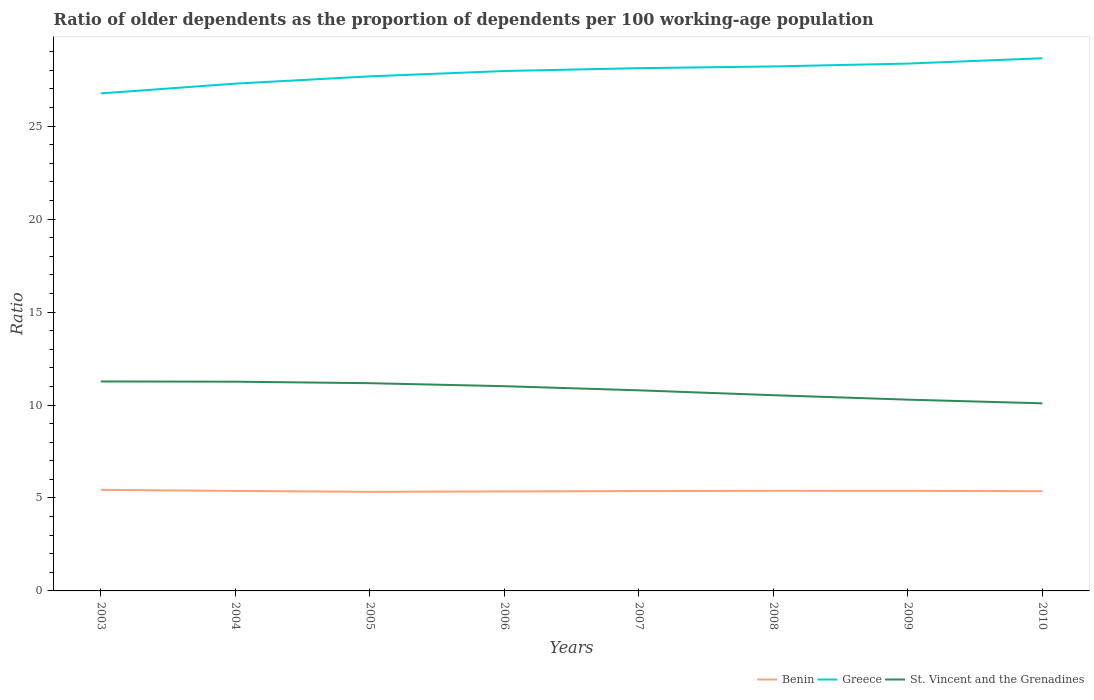Across all years, what is the maximum age dependency ratio(old) in St. Vincent and the Grenadines?
Make the answer very short. 10.09. What is the total age dependency ratio(old) in Benin in the graph?
Your answer should be compact. -0.01. What is the difference between the highest and the second highest age dependency ratio(old) in St. Vincent and the Grenadines?
Make the answer very short. 1.18. What is the difference between the highest and the lowest age dependency ratio(old) in Greece?
Your response must be concise. 5. Is the age dependency ratio(old) in Greece strictly greater than the age dependency ratio(old) in St. Vincent and the Grenadines over the years?
Your answer should be very brief. No. How many lines are there?
Your answer should be very brief. 3. How many years are there in the graph?
Offer a terse response. 8. What is the difference between two consecutive major ticks on the Y-axis?
Your answer should be compact. 5. Are the values on the major ticks of Y-axis written in scientific E-notation?
Provide a short and direct response. No. Where does the legend appear in the graph?
Provide a short and direct response. Bottom right. How are the legend labels stacked?
Offer a terse response. Horizontal. What is the title of the graph?
Give a very brief answer. Ratio of older dependents as the proportion of dependents per 100 working-age population. Does "Armenia" appear as one of the legend labels in the graph?
Your answer should be very brief. No. What is the label or title of the X-axis?
Ensure brevity in your answer.  Years. What is the label or title of the Y-axis?
Offer a terse response. Ratio. What is the Ratio in Benin in 2003?
Provide a short and direct response. 5.44. What is the Ratio of Greece in 2003?
Ensure brevity in your answer.  26.76. What is the Ratio in St. Vincent and the Grenadines in 2003?
Offer a terse response. 11.27. What is the Ratio of Benin in 2004?
Your answer should be compact. 5.38. What is the Ratio in Greece in 2004?
Give a very brief answer. 27.29. What is the Ratio of St. Vincent and the Grenadines in 2004?
Ensure brevity in your answer.  11.25. What is the Ratio of Benin in 2005?
Give a very brief answer. 5.33. What is the Ratio of Greece in 2005?
Your response must be concise. 27.68. What is the Ratio of St. Vincent and the Grenadines in 2005?
Offer a very short reply. 11.17. What is the Ratio of Benin in 2006?
Your answer should be compact. 5.35. What is the Ratio of Greece in 2006?
Offer a terse response. 27.97. What is the Ratio in St. Vincent and the Grenadines in 2006?
Provide a succinct answer. 11.01. What is the Ratio of Benin in 2007?
Ensure brevity in your answer.  5.37. What is the Ratio of Greece in 2007?
Provide a short and direct response. 28.12. What is the Ratio in St. Vincent and the Grenadines in 2007?
Your answer should be compact. 10.79. What is the Ratio in Benin in 2008?
Provide a short and direct response. 5.38. What is the Ratio of Greece in 2008?
Provide a succinct answer. 28.21. What is the Ratio of St. Vincent and the Grenadines in 2008?
Offer a terse response. 10.53. What is the Ratio in Benin in 2009?
Ensure brevity in your answer.  5.38. What is the Ratio in Greece in 2009?
Give a very brief answer. 28.36. What is the Ratio in St. Vincent and the Grenadines in 2009?
Give a very brief answer. 10.29. What is the Ratio in Benin in 2010?
Provide a succinct answer. 5.36. What is the Ratio in Greece in 2010?
Keep it short and to the point. 28.65. What is the Ratio of St. Vincent and the Grenadines in 2010?
Your answer should be very brief. 10.09. Across all years, what is the maximum Ratio of Benin?
Keep it short and to the point. 5.44. Across all years, what is the maximum Ratio of Greece?
Offer a terse response. 28.65. Across all years, what is the maximum Ratio in St. Vincent and the Grenadines?
Provide a succinct answer. 11.27. Across all years, what is the minimum Ratio of Benin?
Ensure brevity in your answer.  5.33. Across all years, what is the minimum Ratio in Greece?
Provide a short and direct response. 26.76. Across all years, what is the minimum Ratio of St. Vincent and the Grenadines?
Your response must be concise. 10.09. What is the total Ratio of Benin in the graph?
Offer a very short reply. 43. What is the total Ratio in Greece in the graph?
Ensure brevity in your answer.  223.03. What is the total Ratio in St. Vincent and the Grenadines in the graph?
Offer a very short reply. 86.4. What is the difference between the Ratio in Benin in 2003 and that in 2004?
Provide a short and direct response. 0.06. What is the difference between the Ratio in Greece in 2003 and that in 2004?
Provide a short and direct response. -0.53. What is the difference between the Ratio in St. Vincent and the Grenadines in 2003 and that in 2004?
Offer a terse response. 0.01. What is the difference between the Ratio in Benin in 2003 and that in 2005?
Give a very brief answer. 0.11. What is the difference between the Ratio of Greece in 2003 and that in 2005?
Give a very brief answer. -0.92. What is the difference between the Ratio in St. Vincent and the Grenadines in 2003 and that in 2005?
Offer a terse response. 0.09. What is the difference between the Ratio of Benin in 2003 and that in 2006?
Offer a terse response. 0.09. What is the difference between the Ratio in Greece in 2003 and that in 2006?
Provide a short and direct response. -1.2. What is the difference between the Ratio of St. Vincent and the Grenadines in 2003 and that in 2006?
Your response must be concise. 0.25. What is the difference between the Ratio in Benin in 2003 and that in 2007?
Your answer should be compact. 0.07. What is the difference between the Ratio in Greece in 2003 and that in 2007?
Provide a short and direct response. -1.36. What is the difference between the Ratio in St. Vincent and the Grenadines in 2003 and that in 2007?
Keep it short and to the point. 0.48. What is the difference between the Ratio in Benin in 2003 and that in 2008?
Provide a succinct answer. 0.05. What is the difference between the Ratio of Greece in 2003 and that in 2008?
Your answer should be very brief. -1.45. What is the difference between the Ratio of St. Vincent and the Grenadines in 2003 and that in 2008?
Your answer should be compact. 0.74. What is the difference between the Ratio of Benin in 2003 and that in 2009?
Provide a succinct answer. 0.06. What is the difference between the Ratio of Greece in 2003 and that in 2009?
Ensure brevity in your answer.  -1.6. What is the difference between the Ratio in St. Vincent and the Grenadines in 2003 and that in 2009?
Provide a short and direct response. 0.98. What is the difference between the Ratio in Benin in 2003 and that in 2010?
Offer a very short reply. 0.07. What is the difference between the Ratio in Greece in 2003 and that in 2010?
Your response must be concise. -1.89. What is the difference between the Ratio of St. Vincent and the Grenadines in 2003 and that in 2010?
Ensure brevity in your answer.  1.18. What is the difference between the Ratio of Benin in 2004 and that in 2005?
Provide a succinct answer. 0.05. What is the difference between the Ratio in Greece in 2004 and that in 2005?
Your answer should be compact. -0.39. What is the difference between the Ratio of St. Vincent and the Grenadines in 2004 and that in 2005?
Offer a very short reply. 0.08. What is the difference between the Ratio of Benin in 2004 and that in 2006?
Your response must be concise. 0.03. What is the difference between the Ratio of Greece in 2004 and that in 2006?
Make the answer very short. -0.68. What is the difference between the Ratio of St. Vincent and the Grenadines in 2004 and that in 2006?
Ensure brevity in your answer.  0.24. What is the difference between the Ratio in Benin in 2004 and that in 2007?
Offer a very short reply. 0.01. What is the difference between the Ratio in Greece in 2004 and that in 2007?
Your response must be concise. -0.83. What is the difference between the Ratio in St. Vincent and the Grenadines in 2004 and that in 2007?
Your response must be concise. 0.47. What is the difference between the Ratio in Benin in 2004 and that in 2008?
Your response must be concise. -0.01. What is the difference between the Ratio in Greece in 2004 and that in 2008?
Give a very brief answer. -0.92. What is the difference between the Ratio in St. Vincent and the Grenadines in 2004 and that in 2008?
Give a very brief answer. 0.73. What is the difference between the Ratio in Benin in 2004 and that in 2009?
Ensure brevity in your answer.  -0. What is the difference between the Ratio in Greece in 2004 and that in 2009?
Offer a very short reply. -1.08. What is the difference between the Ratio in St. Vincent and the Grenadines in 2004 and that in 2009?
Provide a short and direct response. 0.97. What is the difference between the Ratio of Benin in 2004 and that in 2010?
Offer a terse response. 0.02. What is the difference between the Ratio in Greece in 2004 and that in 2010?
Your response must be concise. -1.36. What is the difference between the Ratio of St. Vincent and the Grenadines in 2004 and that in 2010?
Ensure brevity in your answer.  1.16. What is the difference between the Ratio in Benin in 2005 and that in 2006?
Provide a succinct answer. -0.02. What is the difference between the Ratio of Greece in 2005 and that in 2006?
Offer a terse response. -0.29. What is the difference between the Ratio of St. Vincent and the Grenadines in 2005 and that in 2006?
Provide a succinct answer. 0.16. What is the difference between the Ratio of Benin in 2005 and that in 2007?
Your answer should be compact. -0.04. What is the difference between the Ratio of Greece in 2005 and that in 2007?
Make the answer very short. -0.44. What is the difference between the Ratio in St. Vincent and the Grenadines in 2005 and that in 2007?
Provide a succinct answer. 0.38. What is the difference between the Ratio of Benin in 2005 and that in 2008?
Give a very brief answer. -0.05. What is the difference between the Ratio of Greece in 2005 and that in 2008?
Ensure brevity in your answer.  -0.53. What is the difference between the Ratio in St. Vincent and the Grenadines in 2005 and that in 2008?
Provide a short and direct response. 0.65. What is the difference between the Ratio in Benin in 2005 and that in 2009?
Your answer should be compact. -0.05. What is the difference between the Ratio in Greece in 2005 and that in 2009?
Ensure brevity in your answer.  -0.69. What is the difference between the Ratio in St. Vincent and the Grenadines in 2005 and that in 2009?
Provide a short and direct response. 0.89. What is the difference between the Ratio of Benin in 2005 and that in 2010?
Provide a succinct answer. -0.03. What is the difference between the Ratio in Greece in 2005 and that in 2010?
Offer a terse response. -0.97. What is the difference between the Ratio of St. Vincent and the Grenadines in 2005 and that in 2010?
Provide a short and direct response. 1.08. What is the difference between the Ratio in Benin in 2006 and that in 2007?
Ensure brevity in your answer.  -0.02. What is the difference between the Ratio of Greece in 2006 and that in 2007?
Keep it short and to the point. -0.15. What is the difference between the Ratio in St. Vincent and the Grenadines in 2006 and that in 2007?
Keep it short and to the point. 0.22. What is the difference between the Ratio in Benin in 2006 and that in 2008?
Provide a short and direct response. -0.03. What is the difference between the Ratio of Greece in 2006 and that in 2008?
Make the answer very short. -0.25. What is the difference between the Ratio of St. Vincent and the Grenadines in 2006 and that in 2008?
Your answer should be compact. 0.49. What is the difference between the Ratio in Benin in 2006 and that in 2009?
Your answer should be very brief. -0.03. What is the difference between the Ratio of Greece in 2006 and that in 2009?
Offer a terse response. -0.4. What is the difference between the Ratio of St. Vincent and the Grenadines in 2006 and that in 2009?
Ensure brevity in your answer.  0.72. What is the difference between the Ratio in Benin in 2006 and that in 2010?
Give a very brief answer. -0.01. What is the difference between the Ratio in Greece in 2006 and that in 2010?
Provide a short and direct response. -0.69. What is the difference between the Ratio in St. Vincent and the Grenadines in 2006 and that in 2010?
Provide a succinct answer. 0.92. What is the difference between the Ratio of Benin in 2007 and that in 2008?
Offer a terse response. -0.01. What is the difference between the Ratio of Greece in 2007 and that in 2008?
Your answer should be compact. -0.09. What is the difference between the Ratio of St. Vincent and the Grenadines in 2007 and that in 2008?
Your answer should be very brief. 0.26. What is the difference between the Ratio of Benin in 2007 and that in 2009?
Provide a short and direct response. -0.01. What is the difference between the Ratio of Greece in 2007 and that in 2009?
Give a very brief answer. -0.25. What is the difference between the Ratio in St. Vincent and the Grenadines in 2007 and that in 2009?
Ensure brevity in your answer.  0.5. What is the difference between the Ratio of Benin in 2007 and that in 2010?
Your response must be concise. 0.01. What is the difference between the Ratio in Greece in 2007 and that in 2010?
Provide a succinct answer. -0.53. What is the difference between the Ratio of St. Vincent and the Grenadines in 2007 and that in 2010?
Your answer should be compact. 0.7. What is the difference between the Ratio of Benin in 2008 and that in 2009?
Offer a very short reply. 0. What is the difference between the Ratio in Greece in 2008 and that in 2009?
Offer a terse response. -0.15. What is the difference between the Ratio of St. Vincent and the Grenadines in 2008 and that in 2009?
Make the answer very short. 0.24. What is the difference between the Ratio in Benin in 2008 and that in 2010?
Your answer should be very brief. 0.02. What is the difference between the Ratio of Greece in 2008 and that in 2010?
Make the answer very short. -0.44. What is the difference between the Ratio in St. Vincent and the Grenadines in 2008 and that in 2010?
Your answer should be compact. 0.44. What is the difference between the Ratio of Benin in 2009 and that in 2010?
Offer a very short reply. 0.02. What is the difference between the Ratio of Greece in 2009 and that in 2010?
Make the answer very short. -0.29. What is the difference between the Ratio in St. Vincent and the Grenadines in 2009 and that in 2010?
Provide a succinct answer. 0.2. What is the difference between the Ratio of Benin in 2003 and the Ratio of Greece in 2004?
Give a very brief answer. -21.85. What is the difference between the Ratio in Benin in 2003 and the Ratio in St. Vincent and the Grenadines in 2004?
Provide a short and direct response. -5.82. What is the difference between the Ratio of Greece in 2003 and the Ratio of St. Vincent and the Grenadines in 2004?
Ensure brevity in your answer.  15.51. What is the difference between the Ratio in Benin in 2003 and the Ratio in Greece in 2005?
Give a very brief answer. -22.24. What is the difference between the Ratio of Benin in 2003 and the Ratio of St. Vincent and the Grenadines in 2005?
Your answer should be very brief. -5.74. What is the difference between the Ratio in Greece in 2003 and the Ratio in St. Vincent and the Grenadines in 2005?
Offer a very short reply. 15.59. What is the difference between the Ratio of Benin in 2003 and the Ratio of Greece in 2006?
Offer a terse response. -22.53. What is the difference between the Ratio of Benin in 2003 and the Ratio of St. Vincent and the Grenadines in 2006?
Offer a very short reply. -5.57. What is the difference between the Ratio of Greece in 2003 and the Ratio of St. Vincent and the Grenadines in 2006?
Your answer should be compact. 15.75. What is the difference between the Ratio of Benin in 2003 and the Ratio of Greece in 2007?
Your response must be concise. -22.68. What is the difference between the Ratio of Benin in 2003 and the Ratio of St. Vincent and the Grenadines in 2007?
Your answer should be compact. -5.35. What is the difference between the Ratio in Greece in 2003 and the Ratio in St. Vincent and the Grenadines in 2007?
Ensure brevity in your answer.  15.97. What is the difference between the Ratio of Benin in 2003 and the Ratio of Greece in 2008?
Offer a terse response. -22.77. What is the difference between the Ratio in Benin in 2003 and the Ratio in St. Vincent and the Grenadines in 2008?
Your answer should be compact. -5.09. What is the difference between the Ratio in Greece in 2003 and the Ratio in St. Vincent and the Grenadines in 2008?
Offer a very short reply. 16.23. What is the difference between the Ratio of Benin in 2003 and the Ratio of Greece in 2009?
Ensure brevity in your answer.  -22.93. What is the difference between the Ratio in Benin in 2003 and the Ratio in St. Vincent and the Grenadines in 2009?
Ensure brevity in your answer.  -4.85. What is the difference between the Ratio in Greece in 2003 and the Ratio in St. Vincent and the Grenadines in 2009?
Make the answer very short. 16.47. What is the difference between the Ratio of Benin in 2003 and the Ratio of Greece in 2010?
Give a very brief answer. -23.21. What is the difference between the Ratio in Benin in 2003 and the Ratio in St. Vincent and the Grenadines in 2010?
Make the answer very short. -4.65. What is the difference between the Ratio in Greece in 2003 and the Ratio in St. Vincent and the Grenadines in 2010?
Provide a succinct answer. 16.67. What is the difference between the Ratio in Benin in 2004 and the Ratio in Greece in 2005?
Offer a terse response. -22.3. What is the difference between the Ratio in Benin in 2004 and the Ratio in St. Vincent and the Grenadines in 2005?
Keep it short and to the point. -5.8. What is the difference between the Ratio in Greece in 2004 and the Ratio in St. Vincent and the Grenadines in 2005?
Provide a short and direct response. 16.11. What is the difference between the Ratio of Benin in 2004 and the Ratio of Greece in 2006?
Offer a very short reply. -22.59. What is the difference between the Ratio in Benin in 2004 and the Ratio in St. Vincent and the Grenadines in 2006?
Give a very brief answer. -5.63. What is the difference between the Ratio in Greece in 2004 and the Ratio in St. Vincent and the Grenadines in 2006?
Provide a succinct answer. 16.27. What is the difference between the Ratio in Benin in 2004 and the Ratio in Greece in 2007?
Ensure brevity in your answer.  -22.74. What is the difference between the Ratio in Benin in 2004 and the Ratio in St. Vincent and the Grenadines in 2007?
Offer a very short reply. -5.41. What is the difference between the Ratio in Greece in 2004 and the Ratio in St. Vincent and the Grenadines in 2007?
Ensure brevity in your answer.  16.5. What is the difference between the Ratio of Benin in 2004 and the Ratio of Greece in 2008?
Offer a very short reply. -22.83. What is the difference between the Ratio in Benin in 2004 and the Ratio in St. Vincent and the Grenadines in 2008?
Your response must be concise. -5.15. What is the difference between the Ratio in Greece in 2004 and the Ratio in St. Vincent and the Grenadines in 2008?
Offer a very short reply. 16.76. What is the difference between the Ratio in Benin in 2004 and the Ratio in Greece in 2009?
Your answer should be compact. -22.99. What is the difference between the Ratio in Benin in 2004 and the Ratio in St. Vincent and the Grenadines in 2009?
Your answer should be very brief. -4.91. What is the difference between the Ratio of Greece in 2004 and the Ratio of St. Vincent and the Grenadines in 2009?
Provide a short and direct response. 17. What is the difference between the Ratio of Benin in 2004 and the Ratio of Greece in 2010?
Ensure brevity in your answer.  -23.27. What is the difference between the Ratio of Benin in 2004 and the Ratio of St. Vincent and the Grenadines in 2010?
Provide a short and direct response. -4.71. What is the difference between the Ratio of Greece in 2004 and the Ratio of St. Vincent and the Grenadines in 2010?
Make the answer very short. 17.2. What is the difference between the Ratio in Benin in 2005 and the Ratio in Greece in 2006?
Make the answer very short. -22.63. What is the difference between the Ratio in Benin in 2005 and the Ratio in St. Vincent and the Grenadines in 2006?
Your response must be concise. -5.68. What is the difference between the Ratio in Greece in 2005 and the Ratio in St. Vincent and the Grenadines in 2006?
Provide a short and direct response. 16.67. What is the difference between the Ratio of Benin in 2005 and the Ratio of Greece in 2007?
Offer a terse response. -22.79. What is the difference between the Ratio of Benin in 2005 and the Ratio of St. Vincent and the Grenadines in 2007?
Offer a very short reply. -5.46. What is the difference between the Ratio in Greece in 2005 and the Ratio in St. Vincent and the Grenadines in 2007?
Provide a succinct answer. 16.89. What is the difference between the Ratio of Benin in 2005 and the Ratio of Greece in 2008?
Offer a terse response. -22.88. What is the difference between the Ratio of Benin in 2005 and the Ratio of St. Vincent and the Grenadines in 2008?
Your answer should be compact. -5.2. What is the difference between the Ratio of Greece in 2005 and the Ratio of St. Vincent and the Grenadines in 2008?
Your answer should be compact. 17.15. What is the difference between the Ratio of Benin in 2005 and the Ratio of Greece in 2009?
Offer a terse response. -23.03. What is the difference between the Ratio in Benin in 2005 and the Ratio in St. Vincent and the Grenadines in 2009?
Make the answer very short. -4.96. What is the difference between the Ratio in Greece in 2005 and the Ratio in St. Vincent and the Grenadines in 2009?
Your answer should be very brief. 17.39. What is the difference between the Ratio of Benin in 2005 and the Ratio of Greece in 2010?
Give a very brief answer. -23.32. What is the difference between the Ratio of Benin in 2005 and the Ratio of St. Vincent and the Grenadines in 2010?
Provide a short and direct response. -4.76. What is the difference between the Ratio in Greece in 2005 and the Ratio in St. Vincent and the Grenadines in 2010?
Offer a very short reply. 17.59. What is the difference between the Ratio in Benin in 2006 and the Ratio in Greece in 2007?
Offer a very short reply. -22.77. What is the difference between the Ratio in Benin in 2006 and the Ratio in St. Vincent and the Grenadines in 2007?
Your response must be concise. -5.44. What is the difference between the Ratio of Greece in 2006 and the Ratio of St. Vincent and the Grenadines in 2007?
Offer a terse response. 17.18. What is the difference between the Ratio of Benin in 2006 and the Ratio of Greece in 2008?
Your response must be concise. -22.86. What is the difference between the Ratio in Benin in 2006 and the Ratio in St. Vincent and the Grenadines in 2008?
Give a very brief answer. -5.18. What is the difference between the Ratio in Greece in 2006 and the Ratio in St. Vincent and the Grenadines in 2008?
Keep it short and to the point. 17.44. What is the difference between the Ratio in Benin in 2006 and the Ratio in Greece in 2009?
Offer a very short reply. -23.01. What is the difference between the Ratio of Benin in 2006 and the Ratio of St. Vincent and the Grenadines in 2009?
Your response must be concise. -4.94. What is the difference between the Ratio in Greece in 2006 and the Ratio in St. Vincent and the Grenadines in 2009?
Offer a terse response. 17.68. What is the difference between the Ratio of Benin in 2006 and the Ratio of Greece in 2010?
Make the answer very short. -23.3. What is the difference between the Ratio in Benin in 2006 and the Ratio in St. Vincent and the Grenadines in 2010?
Keep it short and to the point. -4.74. What is the difference between the Ratio in Greece in 2006 and the Ratio in St. Vincent and the Grenadines in 2010?
Ensure brevity in your answer.  17.87. What is the difference between the Ratio of Benin in 2007 and the Ratio of Greece in 2008?
Offer a very short reply. -22.84. What is the difference between the Ratio of Benin in 2007 and the Ratio of St. Vincent and the Grenadines in 2008?
Offer a terse response. -5.16. What is the difference between the Ratio of Greece in 2007 and the Ratio of St. Vincent and the Grenadines in 2008?
Provide a succinct answer. 17.59. What is the difference between the Ratio of Benin in 2007 and the Ratio of Greece in 2009?
Offer a terse response. -22.99. What is the difference between the Ratio in Benin in 2007 and the Ratio in St. Vincent and the Grenadines in 2009?
Make the answer very short. -4.92. What is the difference between the Ratio of Greece in 2007 and the Ratio of St. Vincent and the Grenadines in 2009?
Make the answer very short. 17.83. What is the difference between the Ratio of Benin in 2007 and the Ratio of Greece in 2010?
Keep it short and to the point. -23.28. What is the difference between the Ratio in Benin in 2007 and the Ratio in St. Vincent and the Grenadines in 2010?
Your answer should be very brief. -4.72. What is the difference between the Ratio of Greece in 2007 and the Ratio of St. Vincent and the Grenadines in 2010?
Make the answer very short. 18.03. What is the difference between the Ratio in Benin in 2008 and the Ratio in Greece in 2009?
Provide a short and direct response. -22.98. What is the difference between the Ratio in Benin in 2008 and the Ratio in St. Vincent and the Grenadines in 2009?
Offer a very short reply. -4.9. What is the difference between the Ratio in Greece in 2008 and the Ratio in St. Vincent and the Grenadines in 2009?
Make the answer very short. 17.92. What is the difference between the Ratio in Benin in 2008 and the Ratio in Greece in 2010?
Your answer should be compact. -23.27. What is the difference between the Ratio in Benin in 2008 and the Ratio in St. Vincent and the Grenadines in 2010?
Your answer should be very brief. -4.71. What is the difference between the Ratio in Greece in 2008 and the Ratio in St. Vincent and the Grenadines in 2010?
Ensure brevity in your answer.  18.12. What is the difference between the Ratio of Benin in 2009 and the Ratio of Greece in 2010?
Make the answer very short. -23.27. What is the difference between the Ratio of Benin in 2009 and the Ratio of St. Vincent and the Grenadines in 2010?
Ensure brevity in your answer.  -4.71. What is the difference between the Ratio in Greece in 2009 and the Ratio in St. Vincent and the Grenadines in 2010?
Your answer should be compact. 18.27. What is the average Ratio in Benin per year?
Make the answer very short. 5.37. What is the average Ratio of Greece per year?
Offer a terse response. 27.88. What is the average Ratio in St. Vincent and the Grenadines per year?
Your response must be concise. 10.8. In the year 2003, what is the difference between the Ratio of Benin and Ratio of Greece?
Provide a succinct answer. -21.32. In the year 2003, what is the difference between the Ratio in Benin and Ratio in St. Vincent and the Grenadines?
Offer a very short reply. -5.83. In the year 2003, what is the difference between the Ratio of Greece and Ratio of St. Vincent and the Grenadines?
Your answer should be compact. 15.49. In the year 2004, what is the difference between the Ratio of Benin and Ratio of Greece?
Make the answer very short. -21.91. In the year 2004, what is the difference between the Ratio of Benin and Ratio of St. Vincent and the Grenadines?
Provide a succinct answer. -5.88. In the year 2004, what is the difference between the Ratio in Greece and Ratio in St. Vincent and the Grenadines?
Keep it short and to the point. 16.03. In the year 2005, what is the difference between the Ratio in Benin and Ratio in Greece?
Ensure brevity in your answer.  -22.35. In the year 2005, what is the difference between the Ratio in Benin and Ratio in St. Vincent and the Grenadines?
Your answer should be very brief. -5.84. In the year 2005, what is the difference between the Ratio of Greece and Ratio of St. Vincent and the Grenadines?
Provide a short and direct response. 16.5. In the year 2006, what is the difference between the Ratio of Benin and Ratio of Greece?
Your answer should be very brief. -22.61. In the year 2006, what is the difference between the Ratio in Benin and Ratio in St. Vincent and the Grenadines?
Give a very brief answer. -5.66. In the year 2006, what is the difference between the Ratio in Greece and Ratio in St. Vincent and the Grenadines?
Give a very brief answer. 16.95. In the year 2007, what is the difference between the Ratio in Benin and Ratio in Greece?
Your answer should be compact. -22.75. In the year 2007, what is the difference between the Ratio of Benin and Ratio of St. Vincent and the Grenadines?
Your answer should be compact. -5.42. In the year 2007, what is the difference between the Ratio in Greece and Ratio in St. Vincent and the Grenadines?
Provide a succinct answer. 17.33. In the year 2008, what is the difference between the Ratio in Benin and Ratio in Greece?
Offer a terse response. -22.83. In the year 2008, what is the difference between the Ratio in Benin and Ratio in St. Vincent and the Grenadines?
Give a very brief answer. -5.14. In the year 2008, what is the difference between the Ratio in Greece and Ratio in St. Vincent and the Grenadines?
Your response must be concise. 17.68. In the year 2009, what is the difference between the Ratio in Benin and Ratio in Greece?
Provide a short and direct response. -22.98. In the year 2009, what is the difference between the Ratio of Benin and Ratio of St. Vincent and the Grenadines?
Your answer should be very brief. -4.91. In the year 2009, what is the difference between the Ratio of Greece and Ratio of St. Vincent and the Grenadines?
Give a very brief answer. 18.08. In the year 2010, what is the difference between the Ratio in Benin and Ratio in Greece?
Your answer should be very brief. -23.29. In the year 2010, what is the difference between the Ratio of Benin and Ratio of St. Vincent and the Grenadines?
Your answer should be compact. -4.73. In the year 2010, what is the difference between the Ratio in Greece and Ratio in St. Vincent and the Grenadines?
Offer a terse response. 18.56. What is the ratio of the Ratio of Benin in 2003 to that in 2004?
Your response must be concise. 1.01. What is the ratio of the Ratio of Greece in 2003 to that in 2004?
Make the answer very short. 0.98. What is the ratio of the Ratio in St. Vincent and the Grenadines in 2003 to that in 2004?
Keep it short and to the point. 1. What is the ratio of the Ratio of Greece in 2003 to that in 2005?
Offer a very short reply. 0.97. What is the ratio of the Ratio of St. Vincent and the Grenadines in 2003 to that in 2005?
Give a very brief answer. 1.01. What is the ratio of the Ratio in Benin in 2003 to that in 2006?
Your answer should be compact. 1.02. What is the ratio of the Ratio in Greece in 2003 to that in 2006?
Give a very brief answer. 0.96. What is the ratio of the Ratio of St. Vincent and the Grenadines in 2003 to that in 2006?
Ensure brevity in your answer.  1.02. What is the ratio of the Ratio in Benin in 2003 to that in 2007?
Ensure brevity in your answer.  1.01. What is the ratio of the Ratio of Greece in 2003 to that in 2007?
Offer a very short reply. 0.95. What is the ratio of the Ratio in St. Vincent and the Grenadines in 2003 to that in 2007?
Offer a very short reply. 1.04. What is the ratio of the Ratio of Greece in 2003 to that in 2008?
Make the answer very short. 0.95. What is the ratio of the Ratio in St. Vincent and the Grenadines in 2003 to that in 2008?
Your answer should be compact. 1.07. What is the ratio of the Ratio of Benin in 2003 to that in 2009?
Give a very brief answer. 1.01. What is the ratio of the Ratio of Greece in 2003 to that in 2009?
Offer a very short reply. 0.94. What is the ratio of the Ratio in St. Vincent and the Grenadines in 2003 to that in 2009?
Your answer should be very brief. 1.1. What is the ratio of the Ratio of Benin in 2003 to that in 2010?
Offer a terse response. 1.01. What is the ratio of the Ratio in Greece in 2003 to that in 2010?
Offer a very short reply. 0.93. What is the ratio of the Ratio of St. Vincent and the Grenadines in 2003 to that in 2010?
Ensure brevity in your answer.  1.12. What is the ratio of the Ratio of Benin in 2004 to that in 2005?
Offer a terse response. 1.01. What is the ratio of the Ratio of Greece in 2004 to that in 2005?
Offer a terse response. 0.99. What is the ratio of the Ratio of St. Vincent and the Grenadines in 2004 to that in 2005?
Provide a succinct answer. 1.01. What is the ratio of the Ratio in Benin in 2004 to that in 2006?
Make the answer very short. 1.01. What is the ratio of the Ratio in Greece in 2004 to that in 2006?
Provide a succinct answer. 0.98. What is the ratio of the Ratio of St. Vincent and the Grenadines in 2004 to that in 2006?
Ensure brevity in your answer.  1.02. What is the ratio of the Ratio of Benin in 2004 to that in 2007?
Keep it short and to the point. 1. What is the ratio of the Ratio of Greece in 2004 to that in 2007?
Provide a succinct answer. 0.97. What is the ratio of the Ratio in St. Vincent and the Grenadines in 2004 to that in 2007?
Ensure brevity in your answer.  1.04. What is the ratio of the Ratio in Greece in 2004 to that in 2008?
Your answer should be compact. 0.97. What is the ratio of the Ratio of St. Vincent and the Grenadines in 2004 to that in 2008?
Provide a short and direct response. 1.07. What is the ratio of the Ratio of St. Vincent and the Grenadines in 2004 to that in 2009?
Offer a very short reply. 1.09. What is the ratio of the Ratio of Benin in 2004 to that in 2010?
Your answer should be very brief. 1. What is the ratio of the Ratio of St. Vincent and the Grenadines in 2004 to that in 2010?
Your response must be concise. 1.12. What is the ratio of the Ratio of Benin in 2005 to that in 2006?
Offer a very short reply. 1. What is the ratio of the Ratio of St. Vincent and the Grenadines in 2005 to that in 2006?
Provide a succinct answer. 1.01. What is the ratio of the Ratio in Greece in 2005 to that in 2007?
Offer a terse response. 0.98. What is the ratio of the Ratio in St. Vincent and the Grenadines in 2005 to that in 2007?
Make the answer very short. 1.04. What is the ratio of the Ratio of Greece in 2005 to that in 2008?
Offer a very short reply. 0.98. What is the ratio of the Ratio in St. Vincent and the Grenadines in 2005 to that in 2008?
Offer a very short reply. 1.06. What is the ratio of the Ratio of Benin in 2005 to that in 2009?
Your answer should be compact. 0.99. What is the ratio of the Ratio in Greece in 2005 to that in 2009?
Your answer should be compact. 0.98. What is the ratio of the Ratio of St. Vincent and the Grenadines in 2005 to that in 2009?
Keep it short and to the point. 1.09. What is the ratio of the Ratio of Benin in 2005 to that in 2010?
Your response must be concise. 0.99. What is the ratio of the Ratio of St. Vincent and the Grenadines in 2005 to that in 2010?
Your answer should be very brief. 1.11. What is the ratio of the Ratio in St. Vincent and the Grenadines in 2006 to that in 2007?
Your answer should be very brief. 1.02. What is the ratio of the Ratio in Greece in 2006 to that in 2008?
Your answer should be compact. 0.99. What is the ratio of the Ratio of St. Vincent and the Grenadines in 2006 to that in 2008?
Provide a short and direct response. 1.05. What is the ratio of the Ratio in Greece in 2006 to that in 2009?
Offer a very short reply. 0.99. What is the ratio of the Ratio in St. Vincent and the Grenadines in 2006 to that in 2009?
Your answer should be very brief. 1.07. What is the ratio of the Ratio in Greece in 2006 to that in 2010?
Your answer should be very brief. 0.98. What is the ratio of the Ratio of St. Vincent and the Grenadines in 2006 to that in 2010?
Your response must be concise. 1.09. What is the ratio of the Ratio of St. Vincent and the Grenadines in 2007 to that in 2008?
Keep it short and to the point. 1.02. What is the ratio of the Ratio in Benin in 2007 to that in 2009?
Provide a short and direct response. 1. What is the ratio of the Ratio in St. Vincent and the Grenadines in 2007 to that in 2009?
Ensure brevity in your answer.  1.05. What is the ratio of the Ratio in Greece in 2007 to that in 2010?
Your answer should be compact. 0.98. What is the ratio of the Ratio of St. Vincent and the Grenadines in 2007 to that in 2010?
Keep it short and to the point. 1.07. What is the ratio of the Ratio of Benin in 2008 to that in 2009?
Provide a succinct answer. 1. What is the ratio of the Ratio of St. Vincent and the Grenadines in 2008 to that in 2009?
Offer a terse response. 1.02. What is the ratio of the Ratio in Greece in 2008 to that in 2010?
Provide a succinct answer. 0.98. What is the ratio of the Ratio in St. Vincent and the Grenadines in 2008 to that in 2010?
Ensure brevity in your answer.  1.04. What is the ratio of the Ratio in Benin in 2009 to that in 2010?
Provide a succinct answer. 1. What is the ratio of the Ratio of St. Vincent and the Grenadines in 2009 to that in 2010?
Your response must be concise. 1.02. What is the difference between the highest and the second highest Ratio of Benin?
Offer a terse response. 0.05. What is the difference between the highest and the second highest Ratio in Greece?
Your answer should be compact. 0.29. What is the difference between the highest and the second highest Ratio of St. Vincent and the Grenadines?
Provide a short and direct response. 0.01. What is the difference between the highest and the lowest Ratio of Benin?
Provide a succinct answer. 0.11. What is the difference between the highest and the lowest Ratio of Greece?
Your response must be concise. 1.89. What is the difference between the highest and the lowest Ratio in St. Vincent and the Grenadines?
Your answer should be compact. 1.18. 